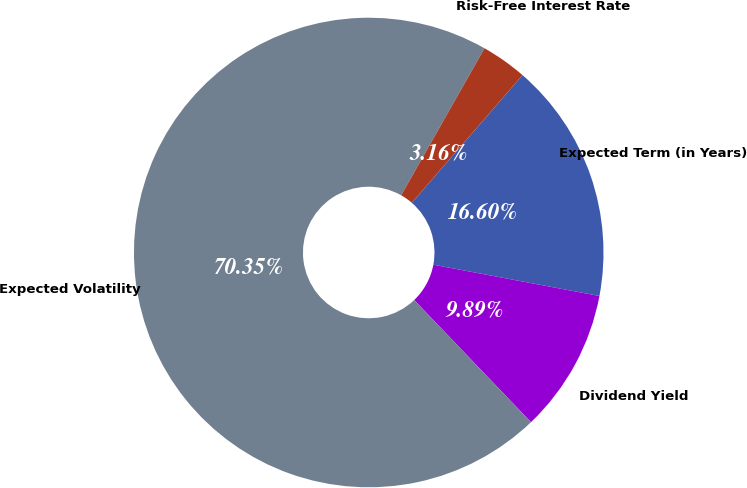Convert chart. <chart><loc_0><loc_0><loc_500><loc_500><pie_chart><fcel>Expected Term (in Years)<fcel>Dividend Yield<fcel>Expected Volatility<fcel>Risk-Free Interest Rate<nl><fcel>16.6%<fcel>9.89%<fcel>70.36%<fcel>3.16%<nl></chart> 